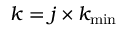Convert formula to latex. <formula><loc_0><loc_0><loc_500><loc_500>k = j \times k _ { \min }</formula> 